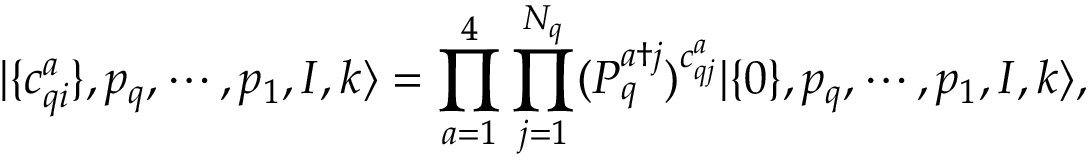Convert formula to latex. <formula><loc_0><loc_0><loc_500><loc_500>| \{ c _ { q i } ^ { a } \} , p _ { q } , \cdots , p _ { 1 } , I , k \rangle = \prod _ { a = 1 } ^ { 4 } \prod _ { j = 1 } ^ { N _ { q } } ( P _ { q } ^ { a \dagger j } ) ^ { c _ { q j } ^ { a } } | \{ 0 \} , p _ { q } , \cdots , p _ { 1 } , I , k \rangle ,</formula> 